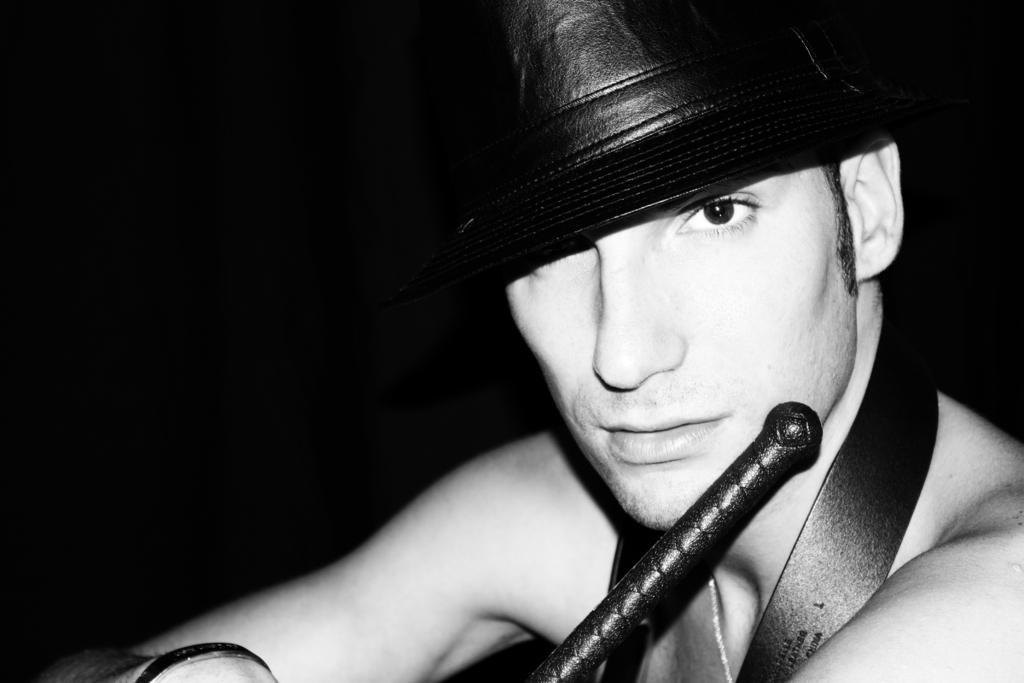How would you summarize this image in a sentence or two? In this image I can see a man and I can see he is wearing a hat. I can also see an object over here and a belt. I can also see this image is black and white in colour and I can see this image is little bit in dark from background. 